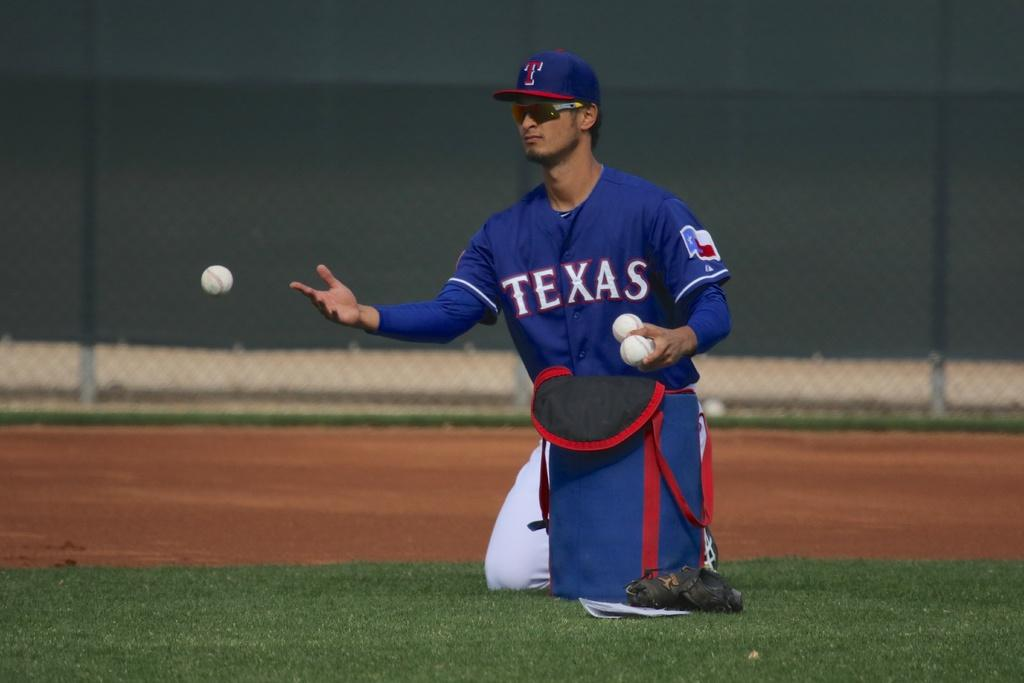<image>
Describe the image concisely. A player in a Texas jersey on his knees tossing baseballs. 